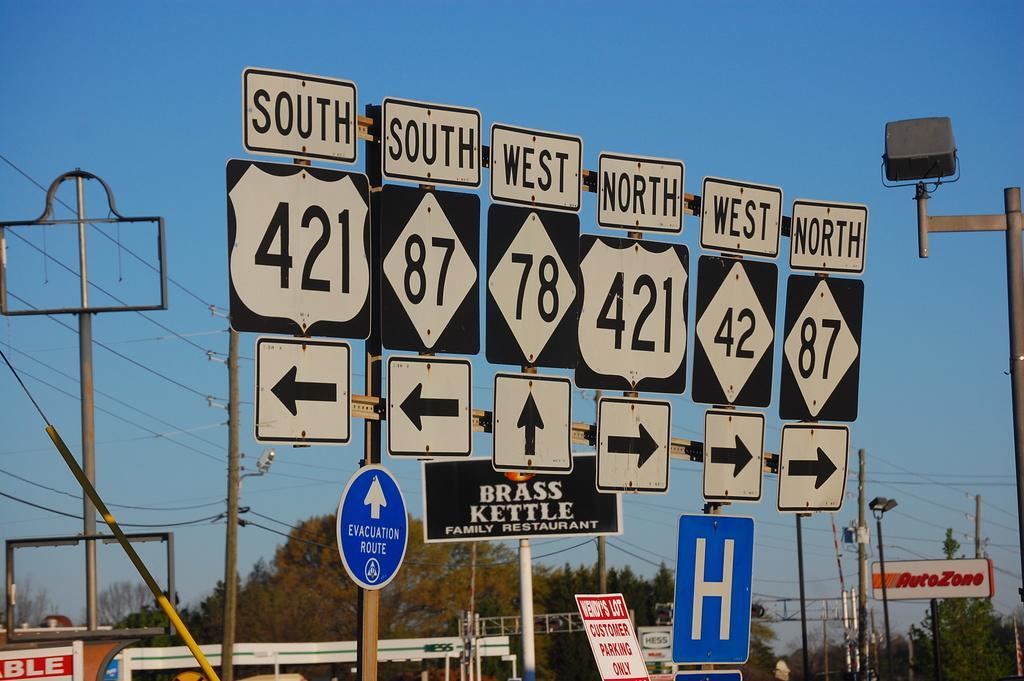<image>
Write a terse but informative summary of the picture. Several interstate signs with different numbers and arrows are lined up, in a row near several businesses like the Brass Kettle. 